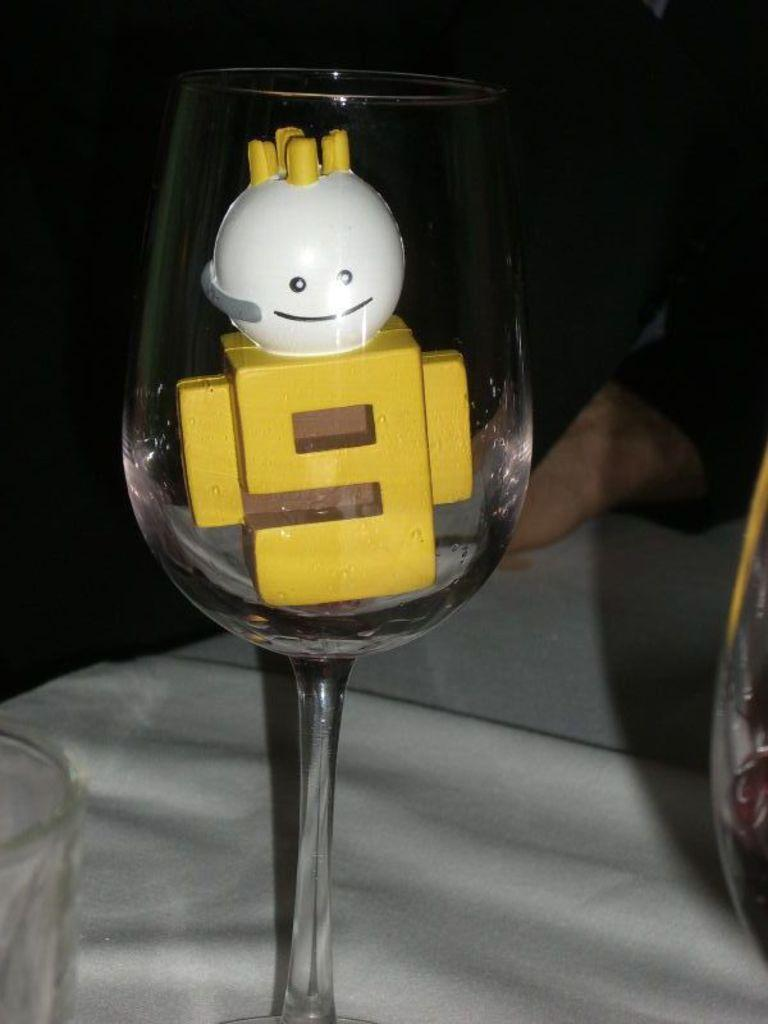What is placed in a glass in the image? There is a toy placed in a glass in the image. Can you see a goat sitting on a chair next to the glass in the image? There is no goat or chair present in the image; it only features a toy placed in a glass. 